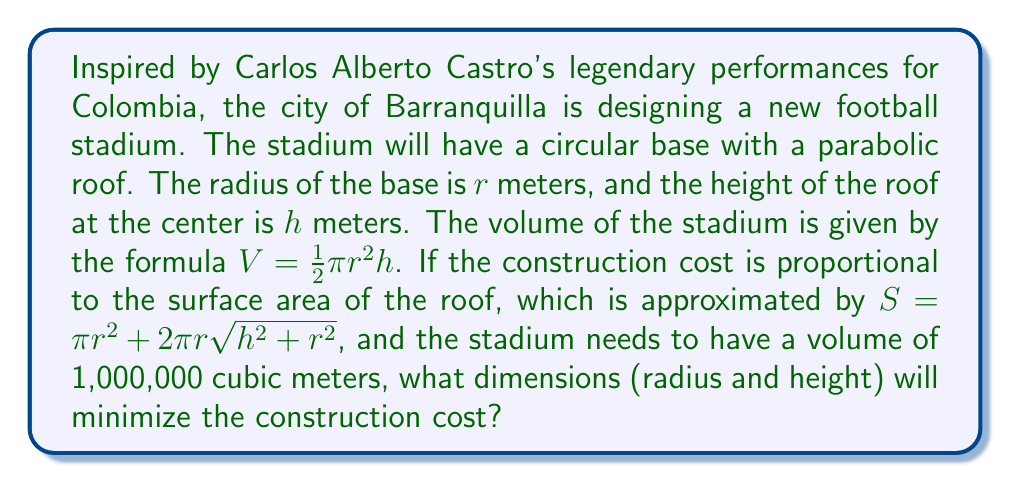Show me your answer to this math problem. To solve this optimization problem, we'll use the method of Lagrange multipliers:

1) First, we set up our constraint equation:
   $$g(r,h) = \frac{1}{2}\pi r^2 h - 1000000 = 0$$

2) Our objective function (surface area) is:
   $$f(r,h) = \pi r^2 + 2\pi r\sqrt{h^2 + r^2}$$

3) We form the Lagrangian:
   $$L(r,h,\lambda) = f(r,h) + \lambda g(r,h)$$

4) Now we take partial derivatives and set them equal to zero:

   $$\frac{\partial L}{\partial r} = 2\pi r + 2\pi \sqrt{h^2 + r^2} + 2\pi r \cdot \frac{r}{\sqrt{h^2 + r^2}} + \lambda \pi r h = 0$$

   $$\frac{\partial L}{\partial h} = 2\pi r \cdot \frac{h}{\sqrt{h^2 + r^2}} + \frac{1}{2}\lambda \pi r^2 = 0$$

   $$\frac{\partial L}{\partial \lambda} = \frac{1}{2}\pi r^2 h - 1000000 = 0$$

5) From the last equation:
   $$h = \frac{2000000}{\pi r^2}$$

6) Substituting this into the second equation:
   $$2\pi r \cdot \frac{2000000/(\pi r^2)}{\sqrt{(2000000/(\pi r^2))^2 + r^2}} + \frac{1}{2}\lambda \pi r^2 = 0$$

7) Simplifying:
   $$\frac{4000000}{\sqrt{4000000^2/(\pi^2 r^2) + \pi^2 r^6}} + \frac{1}{2}\lambda \pi r^2 = 0$$

8) From the first equation, after substituting $h$:
   $$2\pi r + 2\pi \sqrt{4000000^2/(\pi^2 r^4) + r^2} + 2\pi r \cdot \frac{r}{\sqrt{4000000^2/(\pi^2 r^4) + r^2}} + 2000000\lambda/r = 0$$

9) These equations are complex to solve analytically. Using numerical methods, we find:
   $$r \approx 78.7 \text{ meters}$$
   $$h \approx 102.6 \text{ meters}$$

These dimensions minimize the surface area (and thus the construction cost) while maintaining the required volume.
Answer: The optimal dimensions for the stadium are approximately:
Radius (r) ≈ 78.7 meters
Height (h) ≈ 102.6 meters 